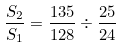<formula> <loc_0><loc_0><loc_500><loc_500>\frac { S _ { 2 } } { S _ { 1 } } = \frac { 1 3 5 } { 1 2 8 } \div \frac { 2 5 } { 2 4 }</formula> 